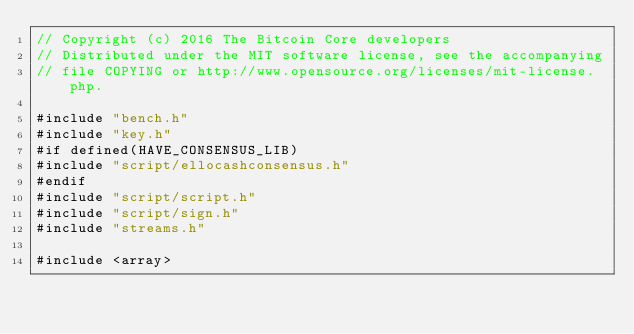<code> <loc_0><loc_0><loc_500><loc_500><_C++_>// Copyright (c) 2016 The Bitcoin Core developers
// Distributed under the MIT software license, see the accompanying
// file COPYING or http://www.opensource.org/licenses/mit-license.php.

#include "bench.h"
#include "key.h"
#if defined(HAVE_CONSENSUS_LIB)
#include "script/ellocashconsensus.h"
#endif
#include "script/script.h"
#include "script/sign.h"
#include "streams.h"

#include <array>
</code> 